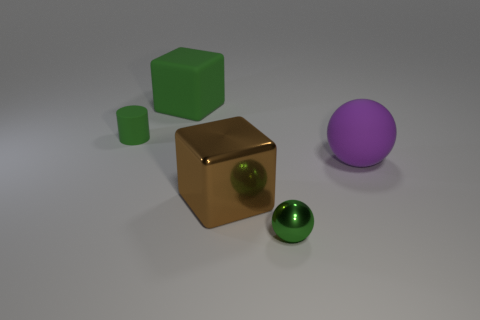What size is the purple object that is made of the same material as the tiny green cylinder?
Provide a short and direct response. Large. How many yellow objects are either metallic blocks or tiny metallic things?
Your answer should be very brief. 0. What shape is the other matte object that is the same color as the small rubber object?
Your answer should be compact. Cube. Is there any other thing that is made of the same material as the small ball?
Your answer should be very brief. Yes. Is the shape of the rubber thing in front of the tiny green cylinder the same as the rubber thing that is to the left of the big matte cube?
Offer a very short reply. No. What number of large cyan shiny balls are there?
Offer a very short reply. 0. What shape is the purple thing that is made of the same material as the large green thing?
Provide a succinct answer. Sphere. Is there any other thing that is the same color as the big rubber sphere?
Offer a terse response. No. Do the metallic sphere and the large rubber object on the right side of the green cube have the same color?
Provide a short and direct response. No. Is the number of matte cubes that are to the right of the green sphere less than the number of green rubber cylinders?
Offer a very short reply. Yes. 